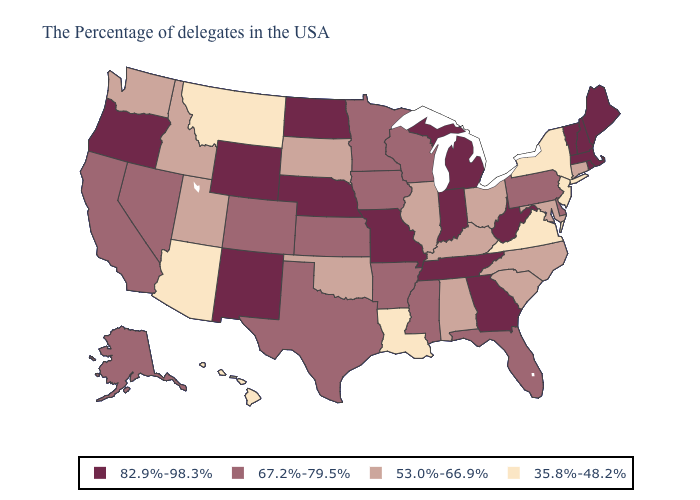What is the value of Mississippi?
Quick response, please. 67.2%-79.5%. Which states have the lowest value in the USA?
Quick response, please. New York, New Jersey, Virginia, Louisiana, Montana, Arizona, Hawaii. Which states have the lowest value in the USA?
Short answer required. New York, New Jersey, Virginia, Louisiana, Montana, Arizona, Hawaii. Does New York have a lower value than Montana?
Give a very brief answer. No. Does Iowa have the same value as New Jersey?
Write a very short answer. No. Which states have the lowest value in the West?
Answer briefly. Montana, Arizona, Hawaii. What is the value of Louisiana?
Be succinct. 35.8%-48.2%. What is the value of Minnesota?
Be succinct. 67.2%-79.5%. Does the map have missing data?
Answer briefly. No. What is the value of Kansas?
Short answer required. 67.2%-79.5%. Among the states that border California , which have the lowest value?
Concise answer only. Arizona. Among the states that border Wyoming , which have the highest value?
Be succinct. Nebraska. What is the value of Oklahoma?
Write a very short answer. 53.0%-66.9%. Which states have the highest value in the USA?
Give a very brief answer. Maine, Massachusetts, Rhode Island, New Hampshire, Vermont, West Virginia, Georgia, Michigan, Indiana, Tennessee, Missouri, Nebraska, North Dakota, Wyoming, New Mexico, Oregon. What is the highest value in the Northeast ?
Be succinct. 82.9%-98.3%. 